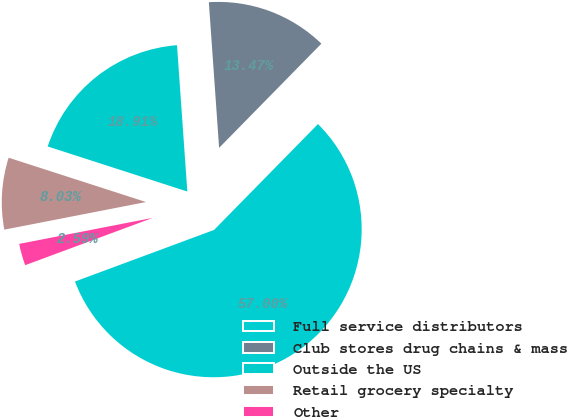Convert chart. <chart><loc_0><loc_0><loc_500><loc_500><pie_chart><fcel>Full service distributors<fcel>Club stores drug chains & mass<fcel>Outside the US<fcel>Retail grocery specialty<fcel>Other<nl><fcel>56.99%<fcel>13.47%<fcel>18.91%<fcel>8.03%<fcel>2.59%<nl></chart> 